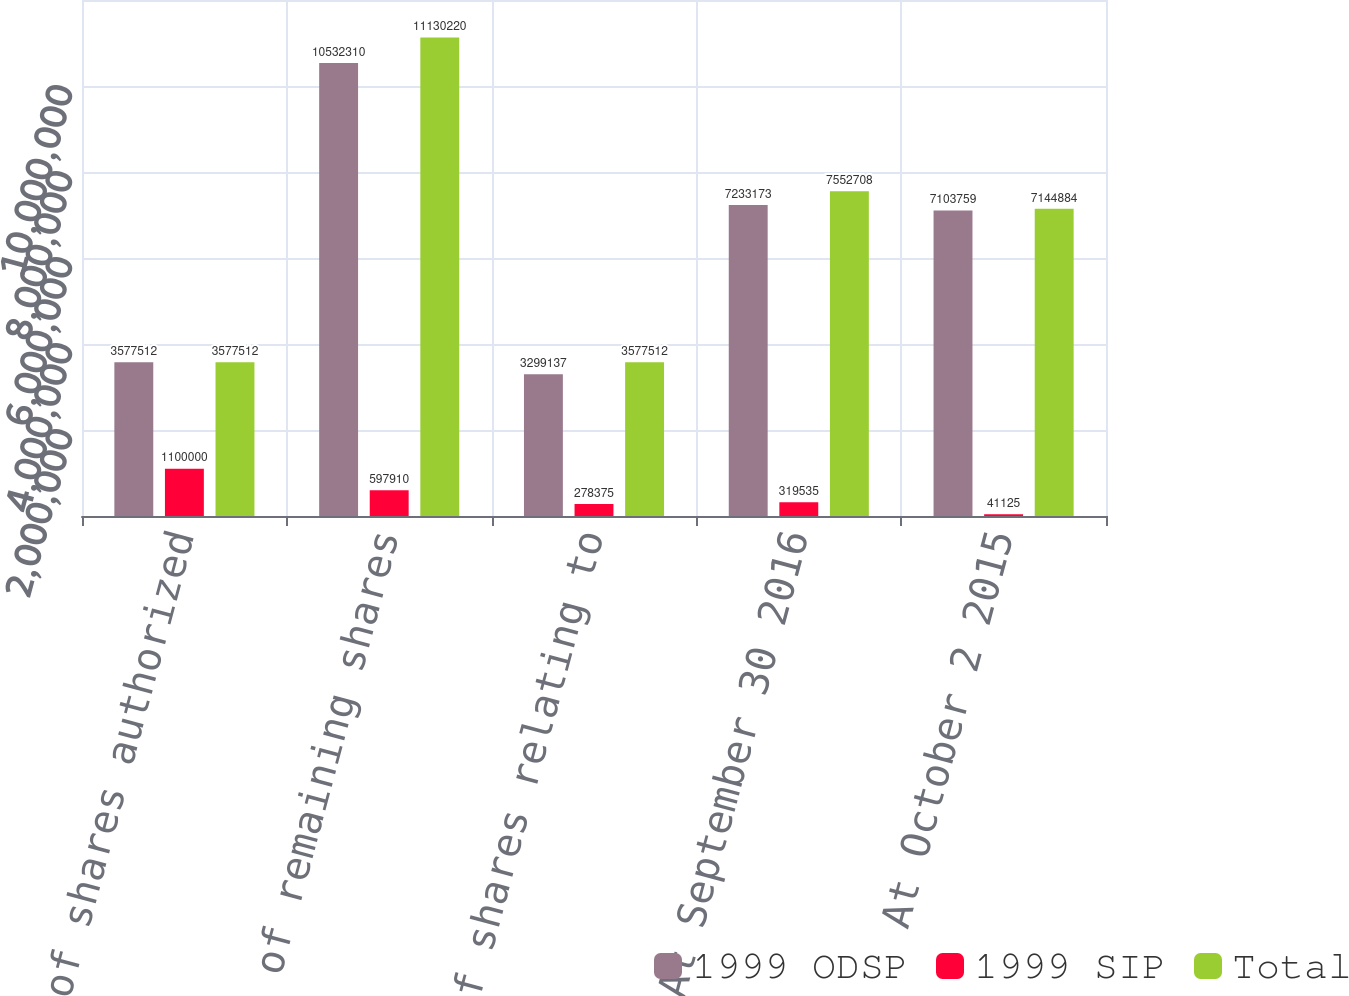Convert chart to OTSL. <chart><loc_0><loc_0><loc_500><loc_500><stacked_bar_chart><ecel><fcel>Number of shares authorized<fcel>Number of remaining shares<fcel>Number of shares relating to<fcel>At September 30 2016<fcel>At October 2 2015<nl><fcel>1999 ODSP<fcel>3.57751e+06<fcel>1.05323e+07<fcel>3.29914e+06<fcel>7.23317e+06<fcel>7.10376e+06<nl><fcel>1999 SIP<fcel>1.1e+06<fcel>597910<fcel>278375<fcel>319535<fcel>41125<nl><fcel>Total<fcel>3.57751e+06<fcel>1.11302e+07<fcel>3.57751e+06<fcel>7.55271e+06<fcel>7.14488e+06<nl></chart> 